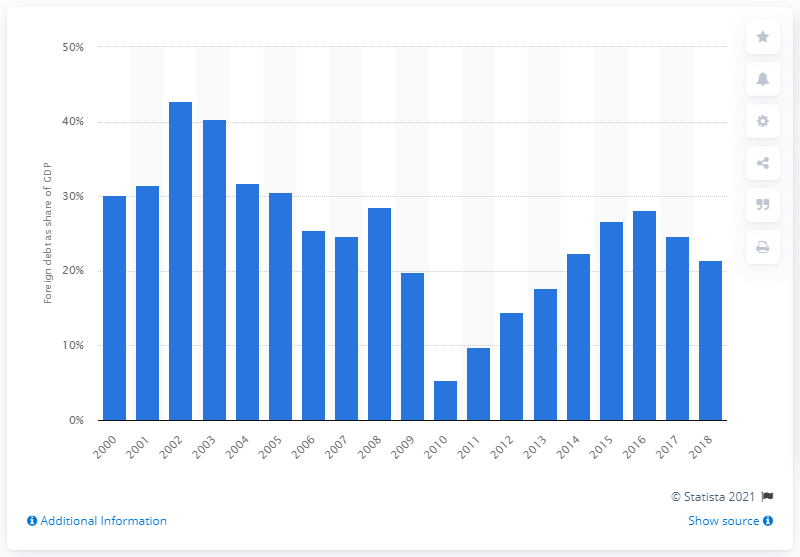Mention a couple of crucial points in this snapshot. In 2018, a significant portion of Haiti's Gross Domestic Product was owed to foreign creditors, amounting to 21.5%. According to data from 2010, Haiti's lowest external debt was 5.3 billion US dollars. 